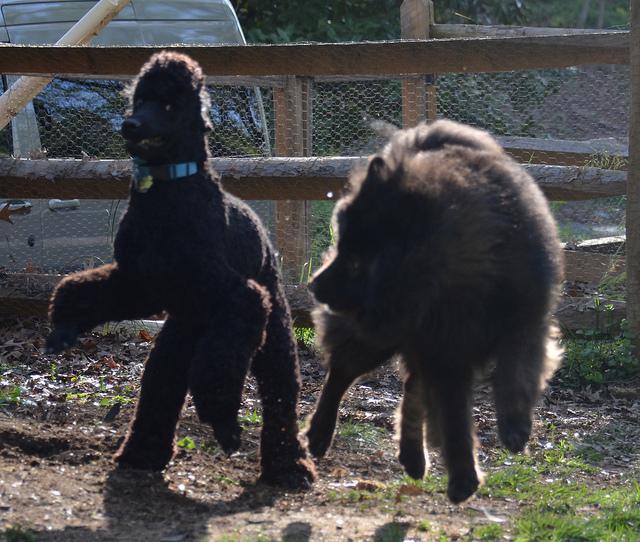How many dogs are in the photo?
Give a very brief answer. 2. How many barefoot people are in the picture?
Give a very brief answer. 0. 